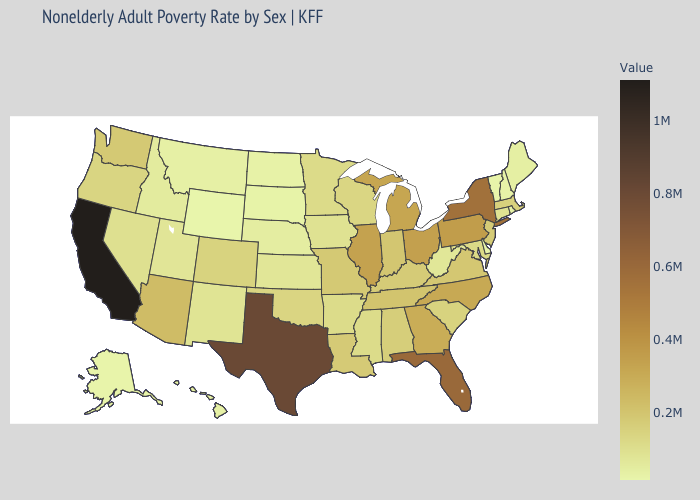Among the states that border Georgia , does Florida have the lowest value?
Be succinct. No. Among the states that border Illinois , does Indiana have the lowest value?
Quick response, please. No. Among the states that border Maryland , which have the lowest value?
Keep it brief. Delaware. Does Nevada have the lowest value in the USA?
Keep it brief. No. Does Ohio have the highest value in the MidWest?
Be succinct. Yes. Does Idaho have the highest value in the USA?
Keep it brief. No. Which states hav the highest value in the West?
Give a very brief answer. California. Does California have the highest value in the USA?
Be succinct. Yes. 